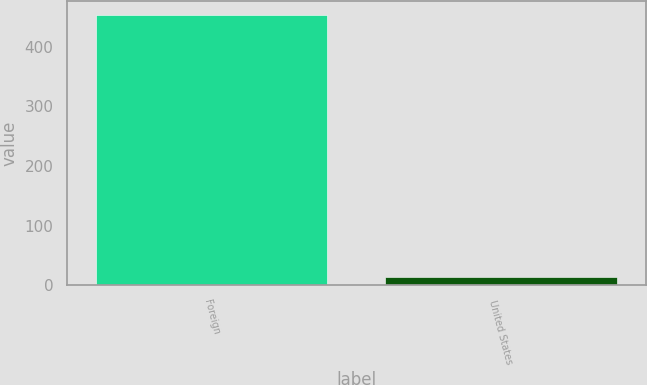<chart> <loc_0><loc_0><loc_500><loc_500><bar_chart><fcel>Foreign<fcel>United States<nl><fcel>453<fcel>15<nl></chart> 